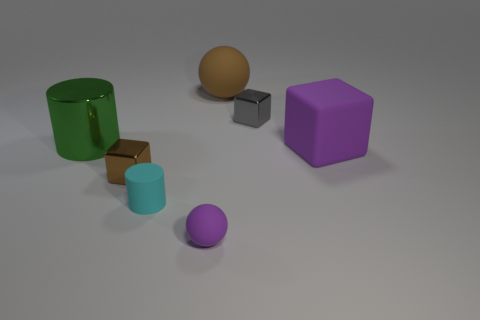Subtract all small blocks. How many blocks are left? 1 Add 1 big green metallic cylinders. How many objects exist? 8 Subtract all spheres. How many objects are left? 5 Add 5 small green matte cubes. How many small green matte cubes exist? 5 Subtract 1 brown balls. How many objects are left? 6 Subtract all cyan matte things. Subtract all large metal cylinders. How many objects are left? 5 Add 6 gray things. How many gray things are left? 7 